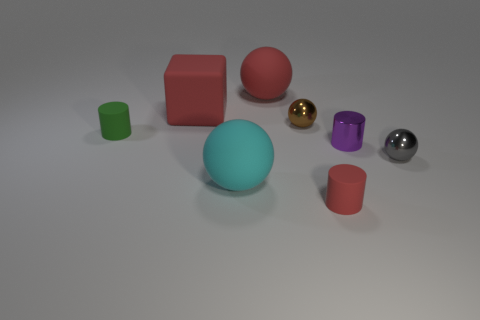Subtract all tiny metal cylinders. How many cylinders are left? 2 Add 1 small cyan rubber blocks. How many objects exist? 9 Subtract all cubes. How many objects are left? 7 Subtract 1 cubes. How many cubes are left? 0 Subtract all red balls. How many balls are left? 3 Subtract 0 yellow spheres. How many objects are left? 8 Subtract all red spheres. Subtract all yellow cubes. How many spheres are left? 3 Subtract all red cylinders. Subtract all small green matte cylinders. How many objects are left? 6 Add 8 cyan rubber things. How many cyan rubber things are left? 9 Add 6 tiny cyan objects. How many tiny cyan objects exist? 6 